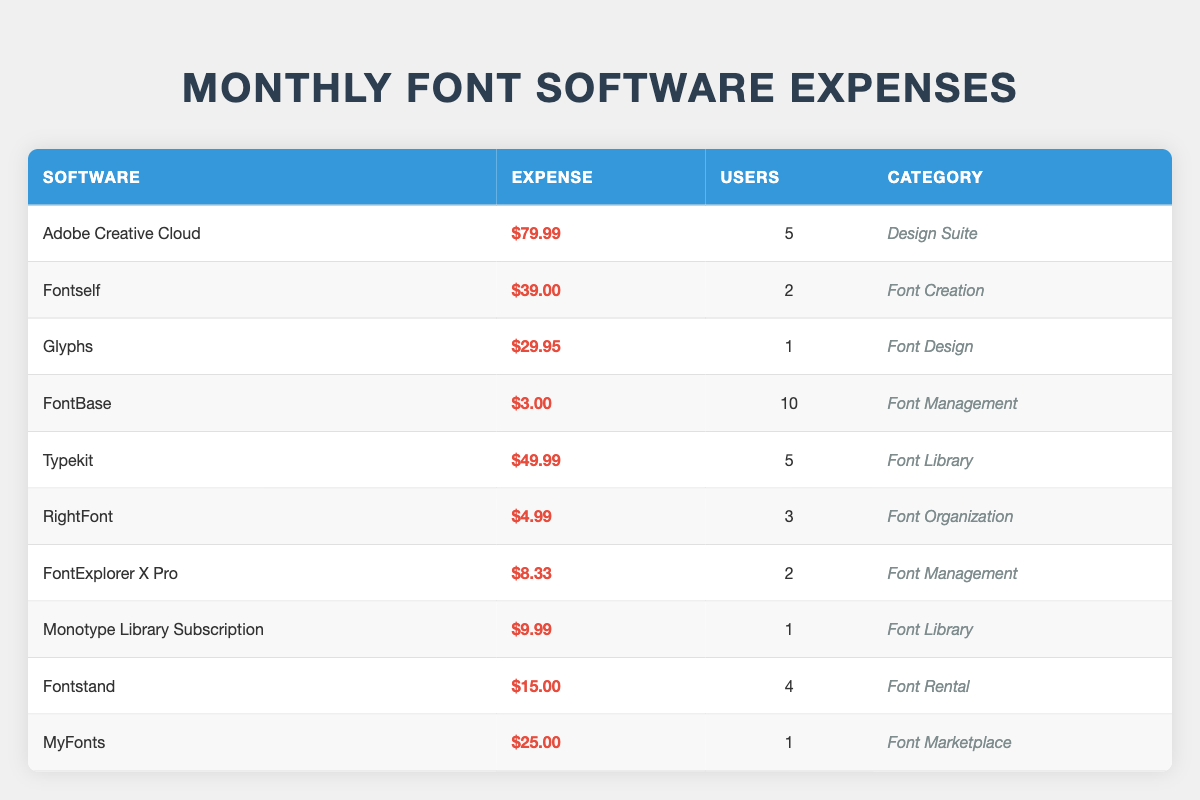What is the total monthly expense for all font-related software subscriptions? To find the total monthly expense, we need to sum up the expenses of all the software listed in the table. The expenses are: 79.99 + 39.00 + 29.95 + 3.00 + 49.99 + 4.99 + 8.33 + 9.99 + 15.00 + 25.00 =  256.24.
Answer: 256.24 Which software has the highest expense? From the table, we compare the expenses: Adobe Creative Cloud has the highest expense of 79.99.
Answer: Adobe Creative Cloud How many users are subscribed to FontBase? The table directly indicates that FontBase has 10 users.
Answer: 10 What is the average monthly expense per user for Fontstand? The total expense of Fontstand is 15.00, and there are 4 users. The average expense per user can be calculated as 15.00 / 4 = 3.75.
Answer: 3.75 Is Typekit more expensive than Fontself? Comparing the expenses, Typekit is 49.99 and Fontself is 39.00. Since 49.99 is greater than 39.00, Typekit is indeed more expensive than Fontself.
Answer: Yes How much do font management tools collectively cost per month? There are two font management tools: FontBase costs 3.00 and FontExplorer X Pro costs 8.33. Adding these gives us 3.00 + 8.33 = 11.33 for the total monthly cost.
Answer: 11.33 How many different categories of font-related software are listed? The table has the following unique categories: Design Suite, Font Creation, Font Design, Font Management, Font Library, Font Organization, Font Rental, and Font Marketplace, totaling 8 distinct categories.
Answer: 8 What is the difference in expenses between the most and least expensive software? The most expensive software is Adobe Creative Cloud at 79.99, and the least expensive is FontBase at 3.00. The difference is 79.99 - 3.00 = 76.99.
Answer: 76.99 Do any software tools have the same expense? Checking the expenses in the table, FontBase (3.00) and RightFont (4.99) have different costs. All expenses listed are unique, so no tools share the same expense amount.
Answer: No 